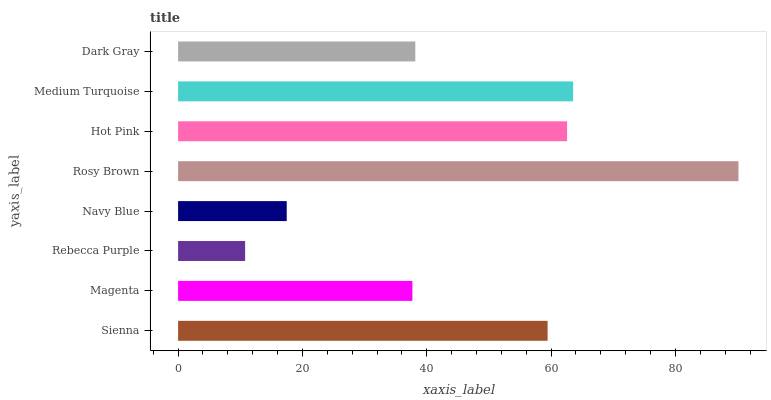Is Rebecca Purple the minimum?
Answer yes or no. Yes. Is Rosy Brown the maximum?
Answer yes or no. Yes. Is Magenta the minimum?
Answer yes or no. No. Is Magenta the maximum?
Answer yes or no. No. Is Sienna greater than Magenta?
Answer yes or no. Yes. Is Magenta less than Sienna?
Answer yes or no. Yes. Is Magenta greater than Sienna?
Answer yes or no. No. Is Sienna less than Magenta?
Answer yes or no. No. Is Sienna the high median?
Answer yes or no. Yes. Is Dark Gray the low median?
Answer yes or no. Yes. Is Dark Gray the high median?
Answer yes or no. No. Is Rebecca Purple the low median?
Answer yes or no. No. 